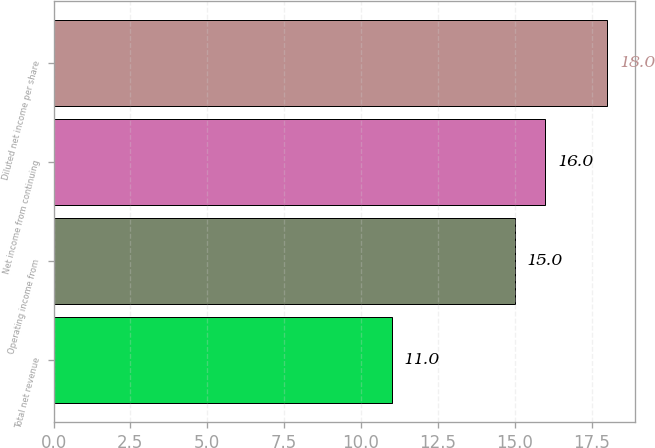Convert chart to OTSL. <chart><loc_0><loc_0><loc_500><loc_500><bar_chart><fcel>Total net revenue<fcel>Operating income from<fcel>Net income from continuing<fcel>Diluted net income per share<nl><fcel>11<fcel>15<fcel>16<fcel>18<nl></chart> 